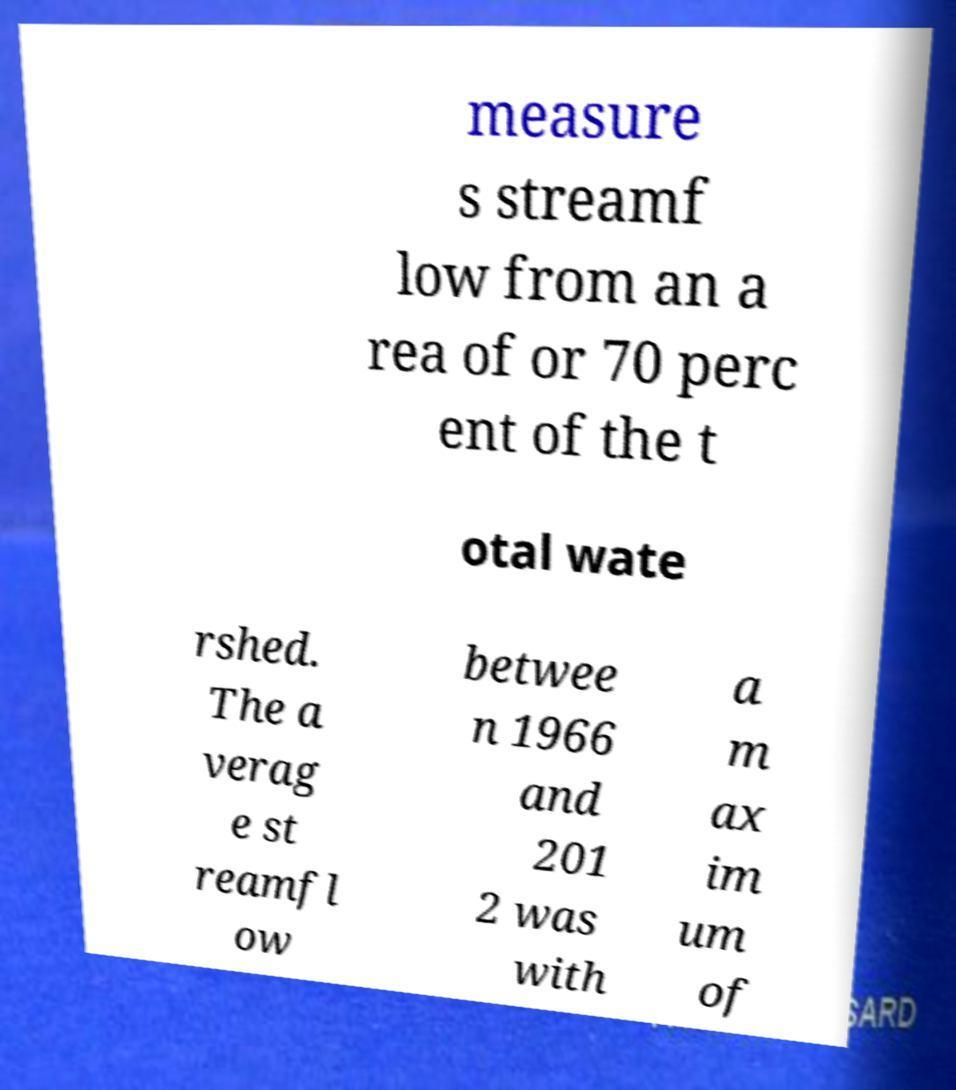What messages or text are displayed in this image? I need them in a readable, typed format. measure s streamf low from an a rea of or 70 perc ent of the t otal wate rshed. The a verag e st reamfl ow betwee n 1966 and 201 2 was with a m ax im um of 